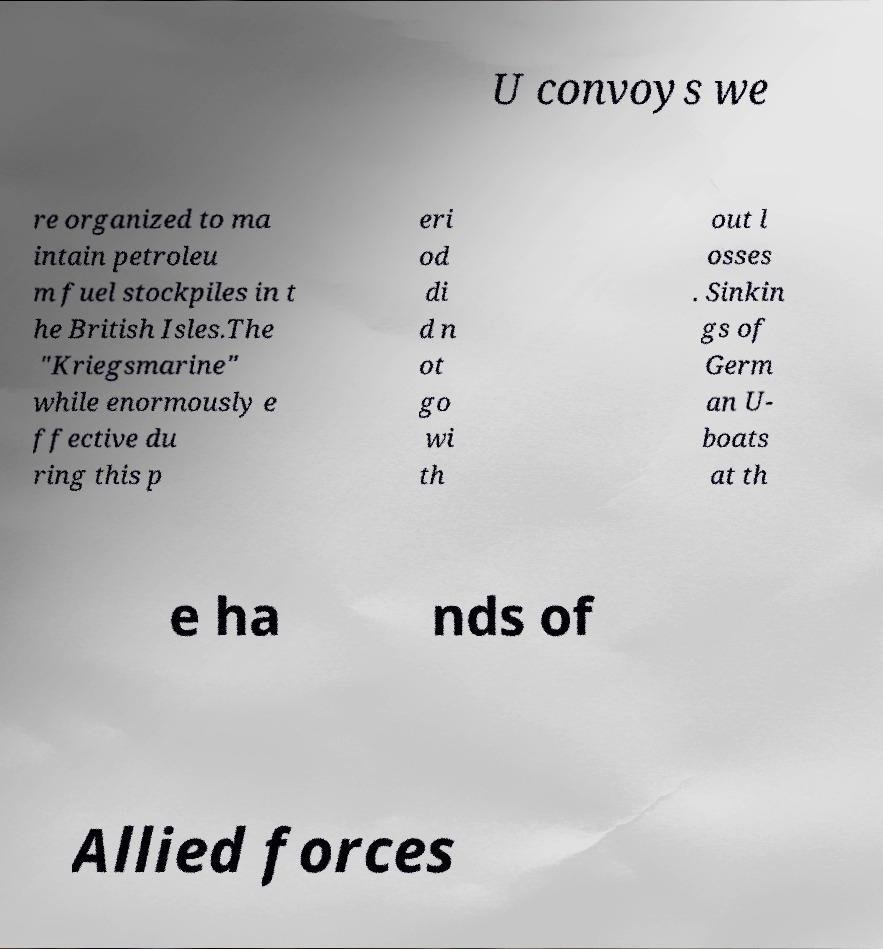I need the written content from this picture converted into text. Can you do that? U convoys we re organized to ma intain petroleu m fuel stockpiles in t he British Isles.The "Kriegsmarine" while enormously e ffective du ring this p eri od di d n ot go wi th out l osses . Sinkin gs of Germ an U- boats at th e ha nds of Allied forces 